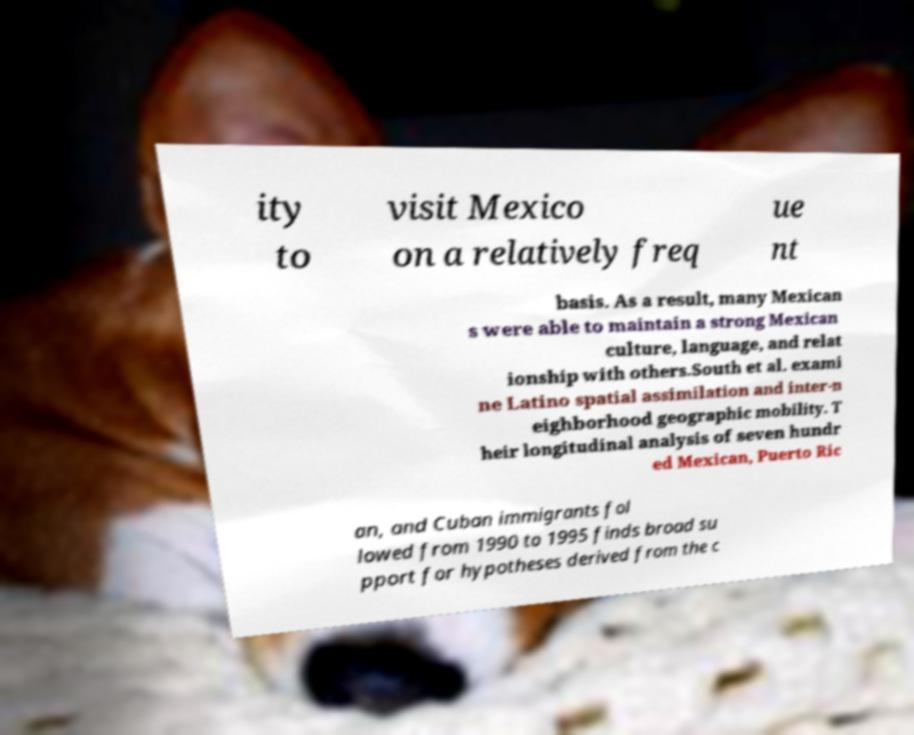Please identify and transcribe the text found in this image. ity to visit Mexico on a relatively freq ue nt basis. As a result, many Mexican s were able to maintain a strong Mexican culture, language, and relat ionship with others.South et al. exami ne Latino spatial assimilation and inter-n eighborhood geographic mobility. T heir longitudinal analysis of seven hundr ed Mexican, Puerto Ric an, and Cuban immigrants fol lowed from 1990 to 1995 finds broad su pport for hypotheses derived from the c 